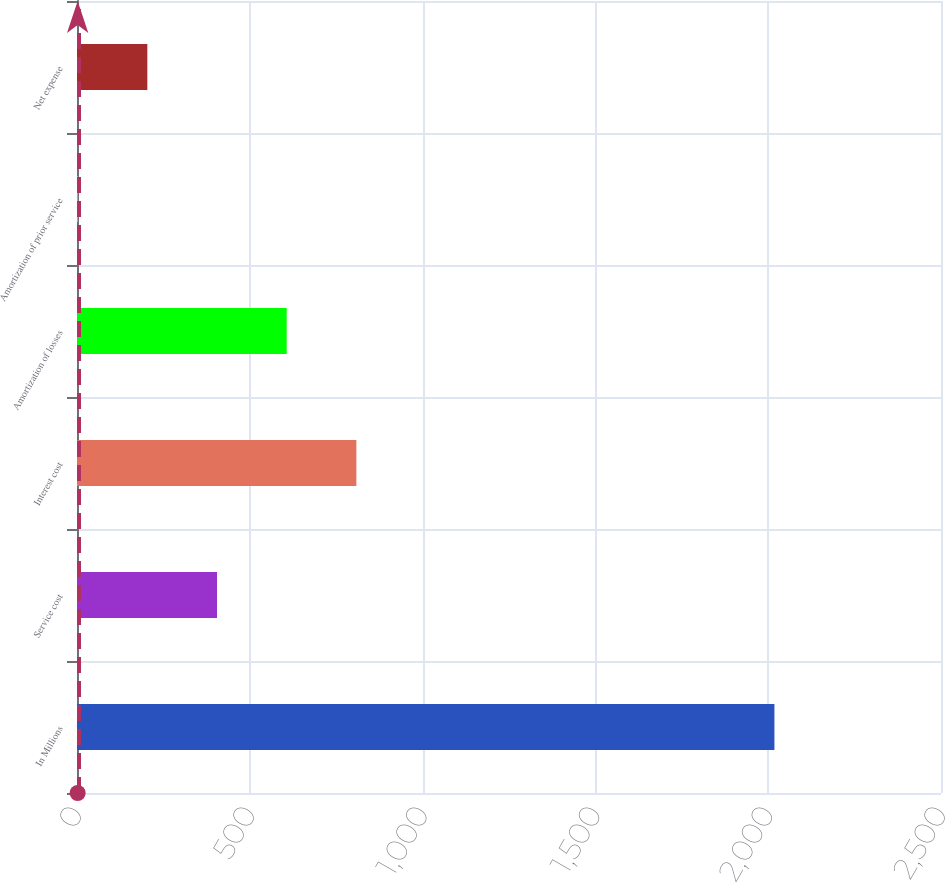<chart> <loc_0><loc_0><loc_500><loc_500><bar_chart><fcel>In Millions<fcel>Service cost<fcel>Interest cost<fcel>Amortization of losses<fcel>Amortization of prior service<fcel>Net expense<nl><fcel>2018<fcel>405.12<fcel>808.34<fcel>606.73<fcel>1.9<fcel>203.51<nl></chart> 